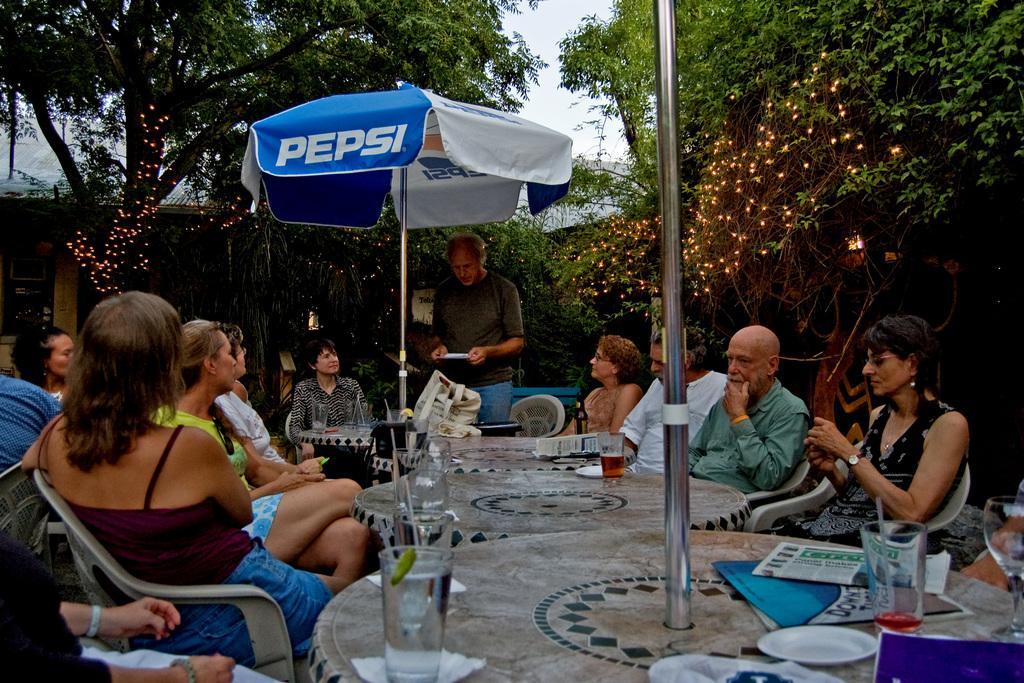Could you give a brief overview of what you see in this image? In this image I can see number of people sitting on chairs. Here I see one man is standing. I can also see number of tables and glasses on these tables. In the background I can see number of trees and lights as a part of decoration. 